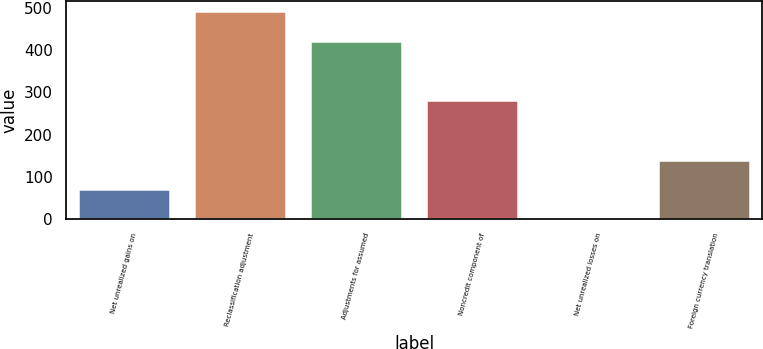Convert chart. <chart><loc_0><loc_0><loc_500><loc_500><bar_chart><fcel>Net unrealized gains on<fcel>Reclassification adjustment<fcel>Adjustments for assumed<fcel>Noncredit component of<fcel>Net unrealized losses on<fcel>Foreign currency translation<nl><fcel>70.44<fcel>491.28<fcel>421.14<fcel>280.86<fcel>0.3<fcel>140.58<nl></chart> 